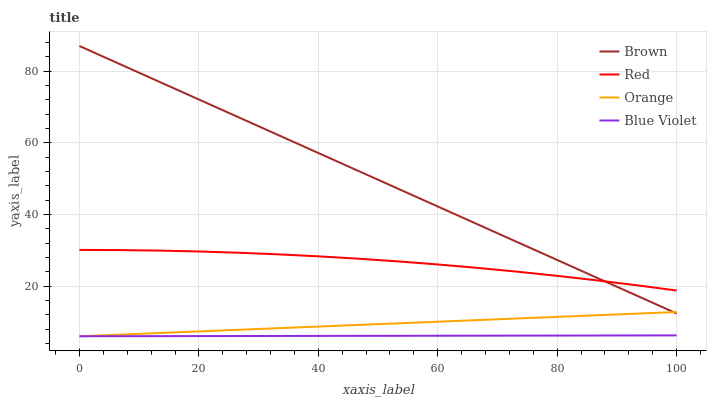Does Blue Violet have the minimum area under the curve?
Answer yes or no. Yes. Does Brown have the maximum area under the curve?
Answer yes or no. Yes. Does Brown have the minimum area under the curve?
Answer yes or no. No. Does Blue Violet have the maximum area under the curve?
Answer yes or no. No. Is Blue Violet the smoothest?
Answer yes or no. Yes. Is Red the roughest?
Answer yes or no. Yes. Is Brown the smoothest?
Answer yes or no. No. Is Brown the roughest?
Answer yes or no. No. Does Orange have the lowest value?
Answer yes or no. Yes. Does Brown have the lowest value?
Answer yes or no. No. Does Brown have the highest value?
Answer yes or no. Yes. Does Blue Violet have the highest value?
Answer yes or no. No. Is Blue Violet less than Brown?
Answer yes or no. Yes. Is Red greater than Orange?
Answer yes or no. Yes. Does Orange intersect Brown?
Answer yes or no. Yes. Is Orange less than Brown?
Answer yes or no. No. Is Orange greater than Brown?
Answer yes or no. No. Does Blue Violet intersect Brown?
Answer yes or no. No. 